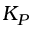<formula> <loc_0><loc_0><loc_500><loc_500>K _ { P }</formula> 